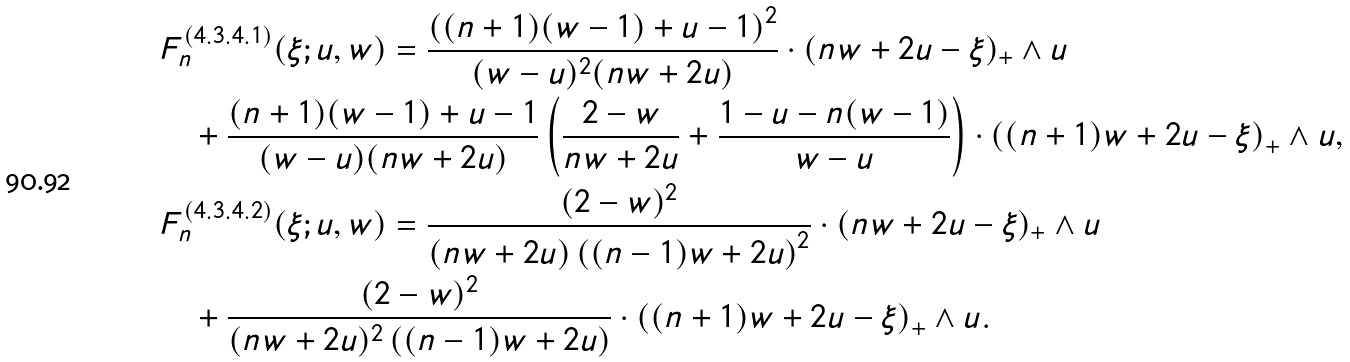Convert formula to latex. <formula><loc_0><loc_0><loc_500><loc_500>& F _ { n } ^ { ( 4 . 3 . 4 . 1 ) } ( \xi ; u , w ) = \frac { \left ( ( n + 1 ) ( w - 1 ) + u - 1 \right ) ^ { 2 } } { ( w - u ) ^ { 2 } ( n w + 2 u ) } \cdot ( n w + 2 u - \xi ) _ { + } \wedge u \\ & \quad + \frac { ( n + 1 ) ( w - 1 ) + u - 1 } { ( w - u ) ( n w + 2 u ) } \left ( \frac { 2 - w } { n w + 2 u } + \frac { 1 - u - n ( w - 1 ) } { w - u } \right ) \cdot \left ( ( n + 1 ) w + 2 u - \xi \right ) _ { + } \wedge u , \\ & F _ { n } ^ { ( 4 . 3 . 4 . 2 ) } ( \xi ; u , w ) = \frac { ( 2 - w ) ^ { 2 } } { ( n w + 2 u ) \left ( ( n - 1 ) w + 2 u \right ) ^ { 2 } } \cdot ( n w + 2 u - \xi ) _ { + } \wedge u \\ & \quad + \frac { ( 2 - w ) ^ { 2 } } { ( n w + 2 u ) ^ { 2 } \left ( ( n - 1 ) w + 2 u \right ) } \cdot \left ( ( n + 1 ) w + 2 u - \xi \right ) _ { + } \wedge u .</formula> 